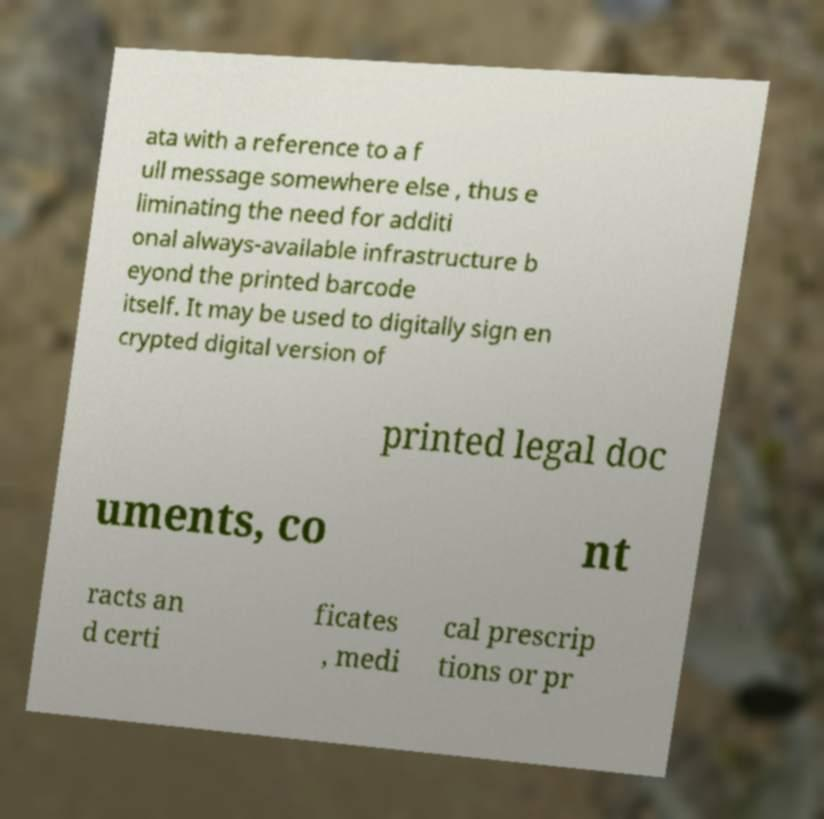Can you read and provide the text displayed in the image?This photo seems to have some interesting text. Can you extract and type it out for me? ata with a reference to a f ull message somewhere else , thus e liminating the need for additi onal always-available infrastructure b eyond the printed barcode itself. It may be used to digitally sign en crypted digital version of printed legal doc uments, co nt racts an d certi ficates , medi cal prescrip tions or pr 